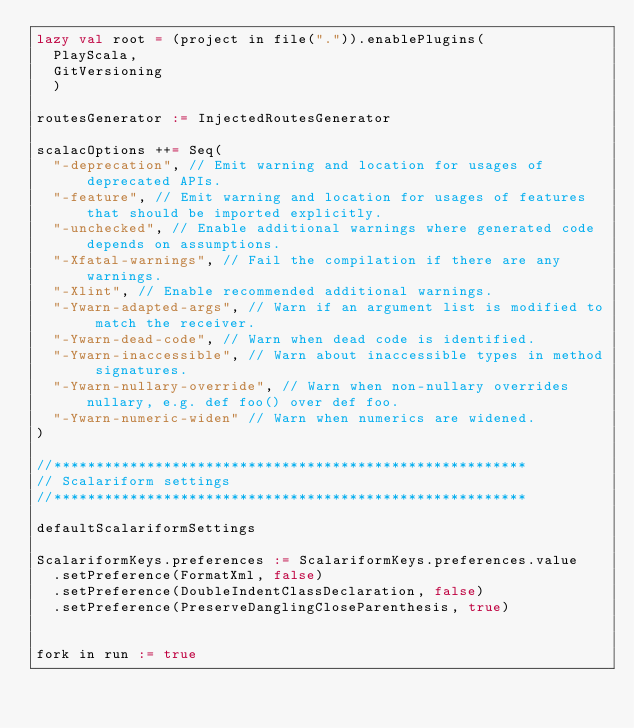Convert code to text. <code><loc_0><loc_0><loc_500><loc_500><_Scala_>lazy val root = (project in file(".")).enablePlugins(
  PlayScala,
  GitVersioning
  )

routesGenerator := InjectedRoutesGenerator

scalacOptions ++= Seq(
  "-deprecation", // Emit warning and location for usages of deprecated APIs.
  "-feature", // Emit warning and location for usages of features that should be imported explicitly.
  "-unchecked", // Enable additional warnings where generated code depends on assumptions.
  "-Xfatal-warnings", // Fail the compilation if there are any warnings.
  "-Xlint", // Enable recommended additional warnings.
  "-Ywarn-adapted-args", // Warn if an argument list is modified to match the receiver.
  "-Ywarn-dead-code", // Warn when dead code is identified.
  "-Ywarn-inaccessible", // Warn about inaccessible types in method signatures.
  "-Ywarn-nullary-override", // Warn when non-nullary overrides nullary, e.g. def foo() over def foo.
  "-Ywarn-numeric-widen" // Warn when numerics are widened.
)

//********************************************************
// Scalariform settings
//********************************************************

defaultScalariformSettings

ScalariformKeys.preferences := ScalariformKeys.preferences.value
  .setPreference(FormatXml, false)
  .setPreference(DoubleIndentClassDeclaration, false)
  .setPreference(PreserveDanglingCloseParenthesis, true)


fork in run := true</code> 